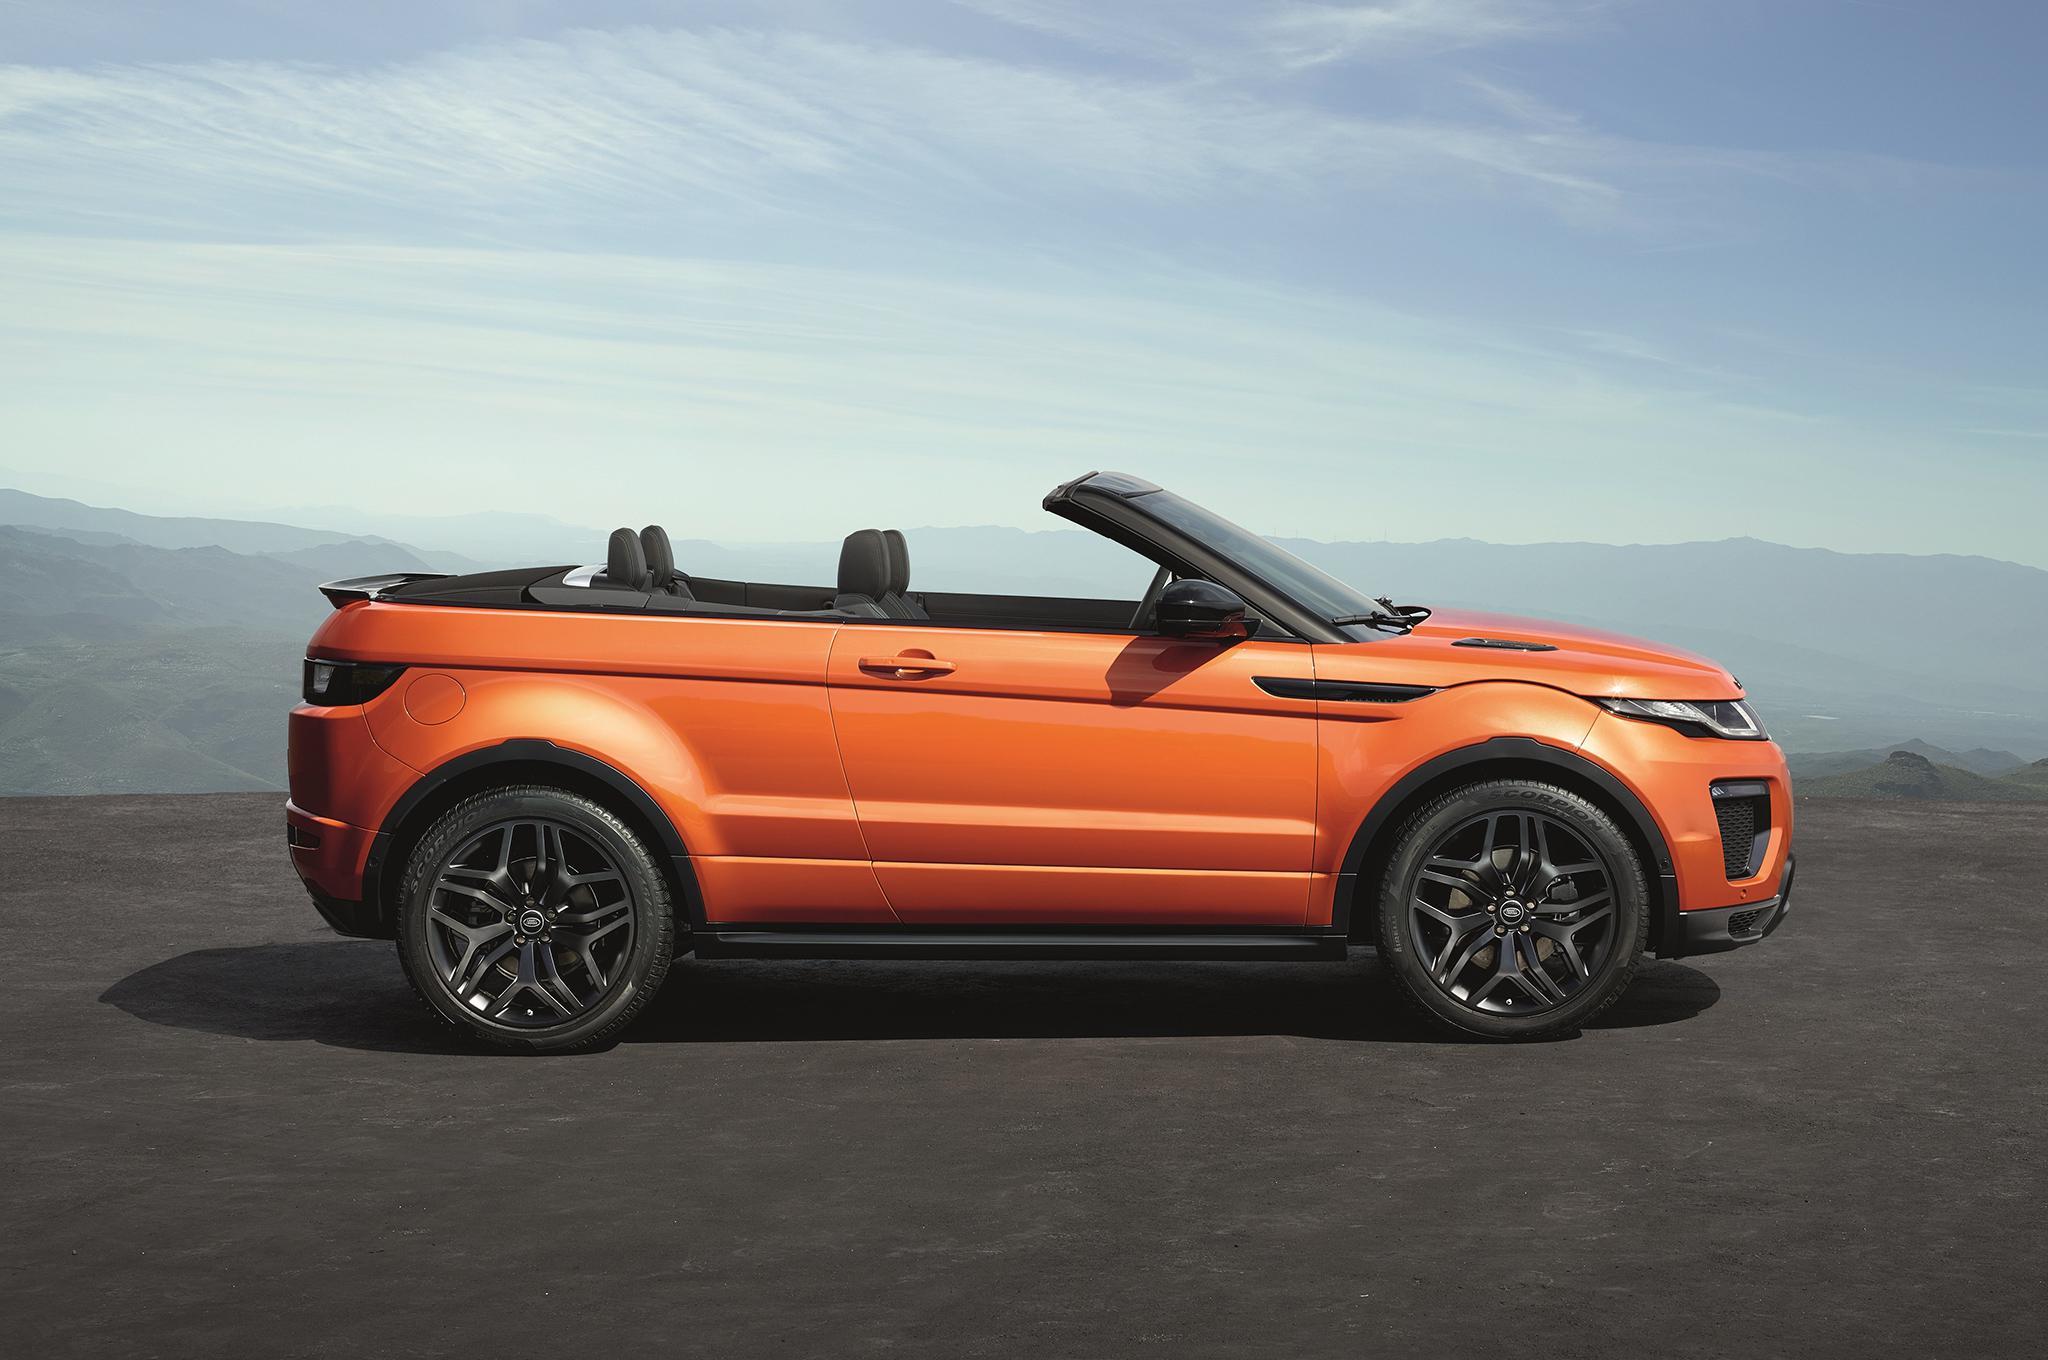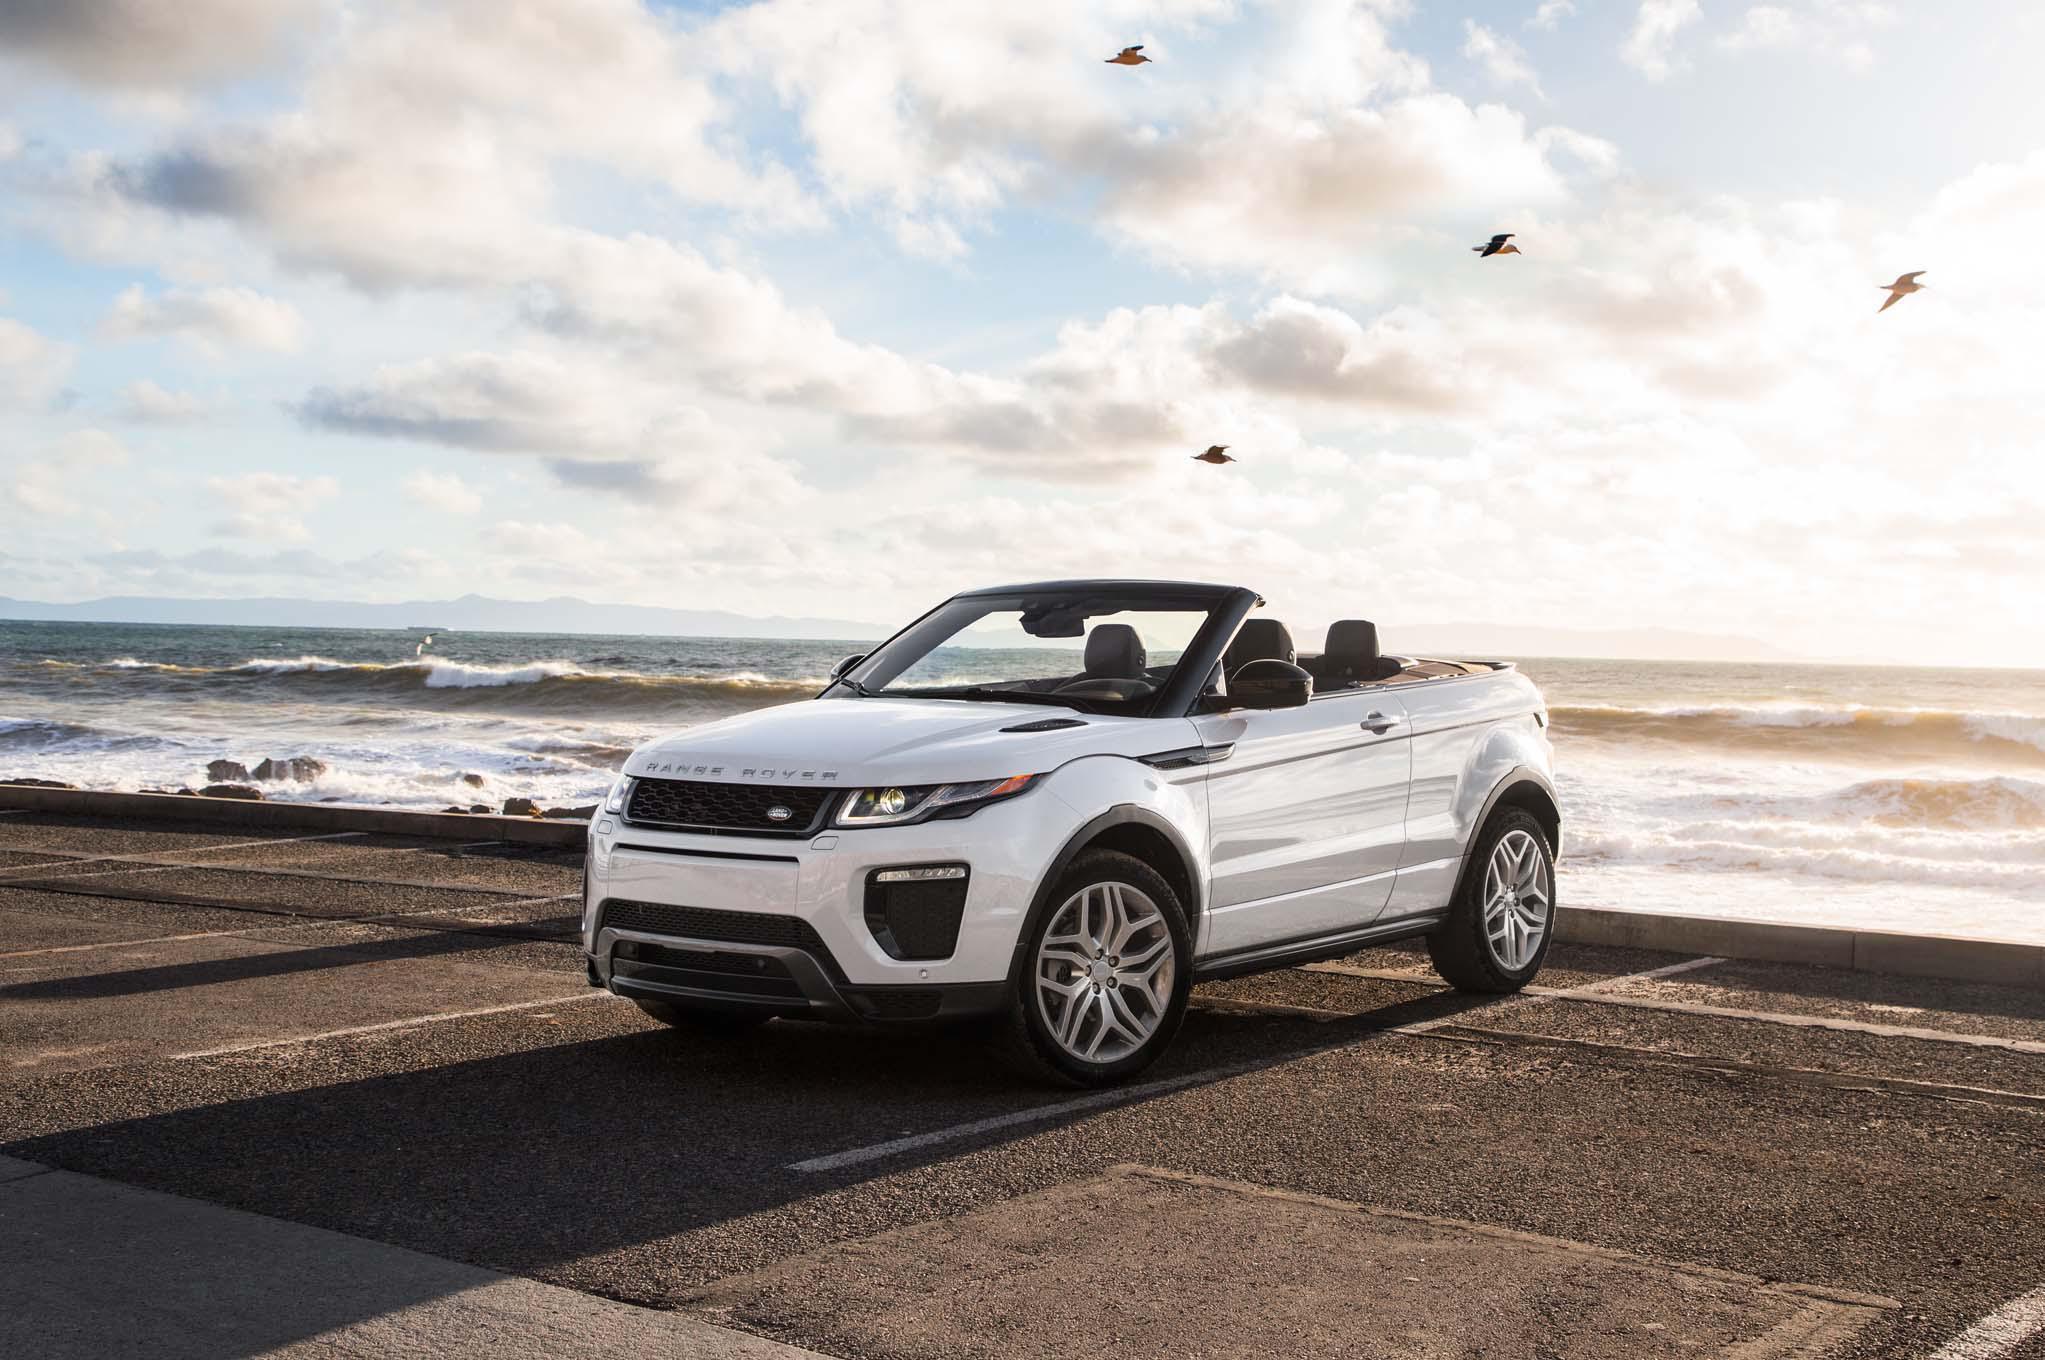The first image is the image on the left, the second image is the image on the right. Considering the images on both sides, is "There is one orange convertible with the top down and one white convertible with the top down" valid? Answer yes or no. Yes. The first image is the image on the left, the second image is the image on the right. Given the left and right images, does the statement "An image shows an orange convertible, which has its top down." hold true? Answer yes or no. Yes. 